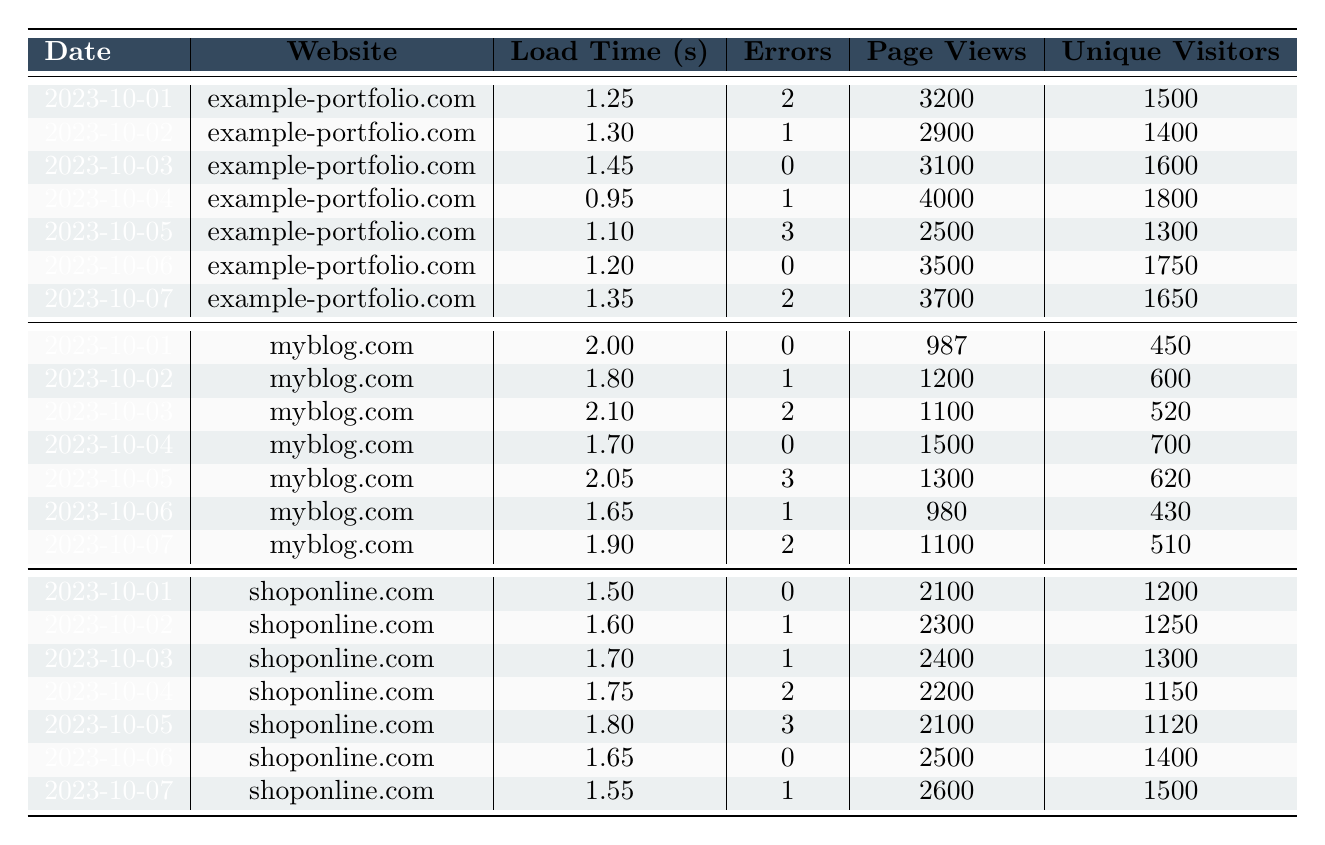What is the load time for myblog.com on 2023-10-01? The table shows that on 2023-10-01, myblog.com has a load time recorded as 2.00 seconds.
Answer: 2.00 seconds How many errors did example-portfolio.com have on 2023-10-05? According to the table, example-portfolio.com had 3 errors on 2023-10-05.
Answer: 3 errors What is the total number of page views for shoponline.com from 2023-10-01 to 2023-10-07? The page views for each date for shoponline.com are 2100, 2300, 2400, 2200, 2100, 2500, and 2600. Adding these gives a total of 2100 + 2300 + 2400 + 2200 + 2100 + 2500 + 2600 = 16800.
Answer: 16800 What was the average load time for all websites on 2023-10-06? The load times on 2023-10-06 are: example-portfolio.com: 1.20 seconds, myblog.com: 1.65 seconds, and shoponline.com: 1.65 seconds. The average is (1.20 + 1.65 + 1.65) / 3 = 1.50 seconds.
Answer: 1.50 seconds Did myblog.com experience more errors than example-portfolio.com on 2023-10-02? On 2023-10-02, myblog.com had 1 error and example-portfolio.com had also 1 error. Since they had the same number, myblog.com did not experience more errors.
Answer: No Which website had the lowest load time on 2023-10-04? On 2023-10-04, the load times were: example-portfolio.com: 0.95 seconds, myblog.com: 1.70 seconds, and shoponline.com: 1.75 seconds. The lowest load time is 0.95 seconds for example-portfolio.com.
Answer: example-portfolio.com What is the percentage of unique visitors to page views for example-portfolio.com on 2023-10-01? On 2023-10-01, example-portfolio.com had 3200 page views and 1500 unique visitors. The percentage is (1500 / 3200) * 100 = 46.875%.
Answer: 46.875% On which date did shoponline.com have the highest error count? By looking at the error counts for shoponline.com, the highest is 3 errors reported on 2023-10-05.
Answer: 2023-10-05 What is the difference in page views between example-portfolio.com and shoponline.com on 2023-10-03? On 2023-10-03, example-portfolio.com had 3100 page views and shoponline.com had 2400 page views. The difference is 3100 - 2400 = 700.
Answer: 700 Which website had the highest number of unique visitors on 2023-10-06? On 2023-10-06, the unique visitors were: example-portfolio.com: 1750, myblog.com: 430, and shoponline.com: 1400. The highest count is 1750 for example-portfolio.com.
Answer: example-portfolio.com 